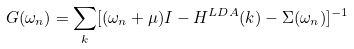<formula> <loc_0><loc_0><loc_500><loc_500>G ( \omega _ { n } ) = \sum _ { k } [ ( \omega _ { n } + \mu ) I - H ^ { L D A } ( k ) - \Sigma ( \omega _ { n } ) ] ^ { - 1 }</formula> 